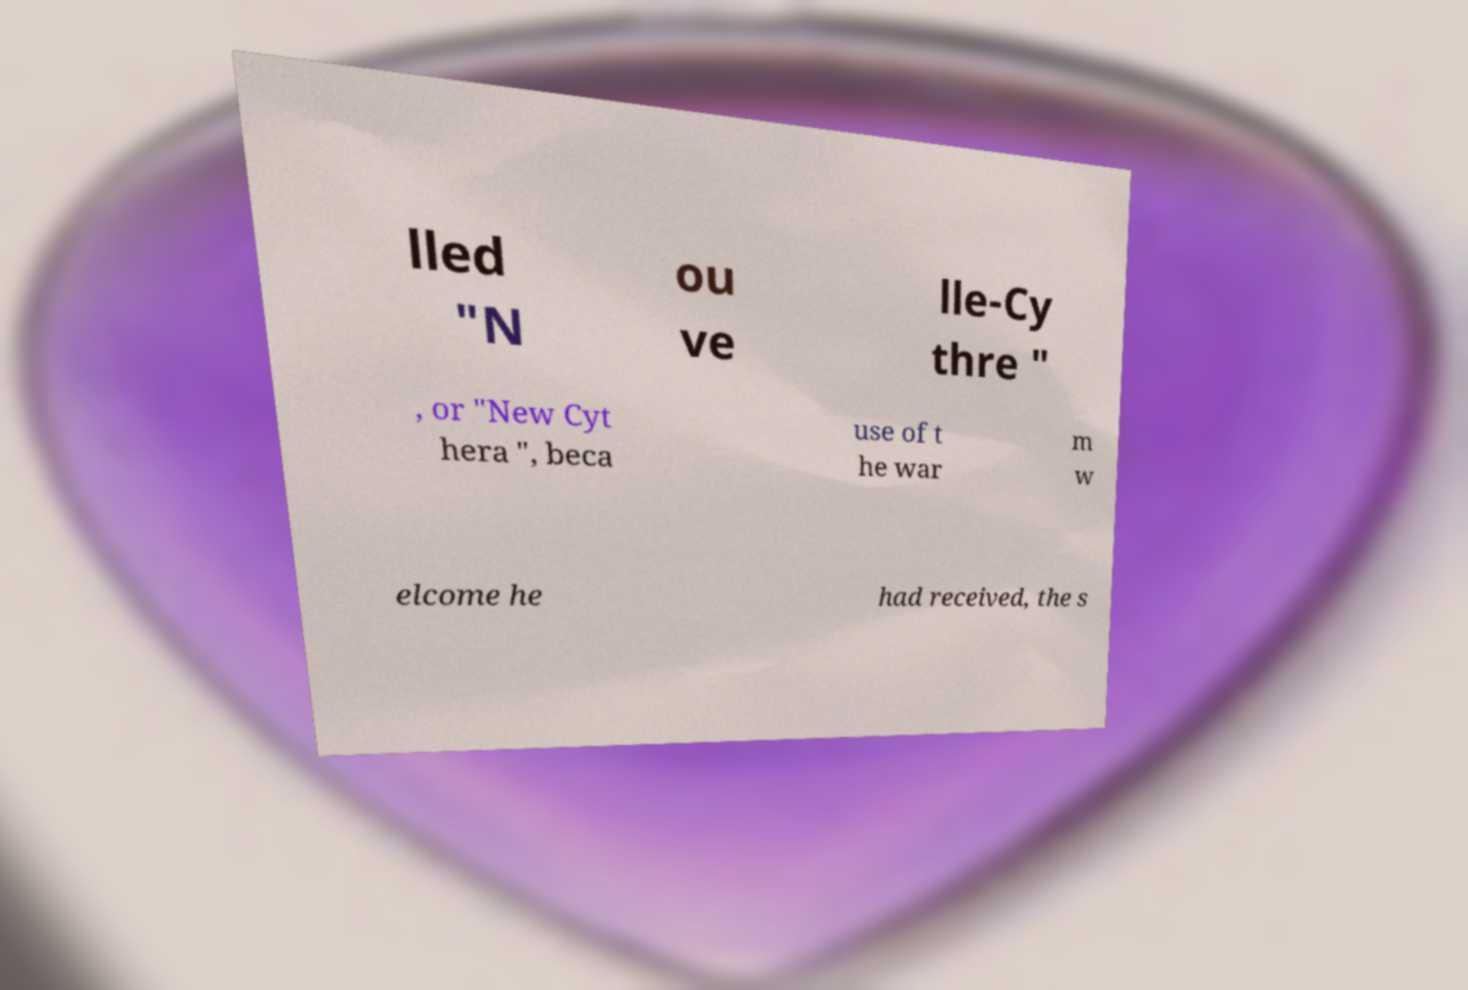There's text embedded in this image that I need extracted. Can you transcribe it verbatim? lled "N ou ve lle-Cy thre " , or "New Cyt hera ", beca use of t he war m w elcome he had received, the s 